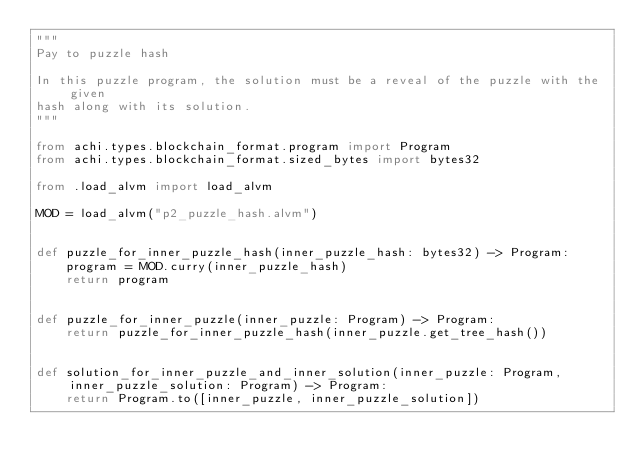<code> <loc_0><loc_0><loc_500><loc_500><_Python_>"""
Pay to puzzle hash

In this puzzle program, the solution must be a reveal of the puzzle with the given
hash along with its solution.
"""

from achi.types.blockchain_format.program import Program
from achi.types.blockchain_format.sized_bytes import bytes32

from .load_alvm import load_alvm

MOD = load_alvm("p2_puzzle_hash.alvm")


def puzzle_for_inner_puzzle_hash(inner_puzzle_hash: bytes32) -> Program:
    program = MOD.curry(inner_puzzle_hash)
    return program


def puzzle_for_inner_puzzle(inner_puzzle: Program) -> Program:
    return puzzle_for_inner_puzzle_hash(inner_puzzle.get_tree_hash())


def solution_for_inner_puzzle_and_inner_solution(inner_puzzle: Program, inner_puzzle_solution: Program) -> Program:
    return Program.to([inner_puzzle, inner_puzzle_solution])
</code> 